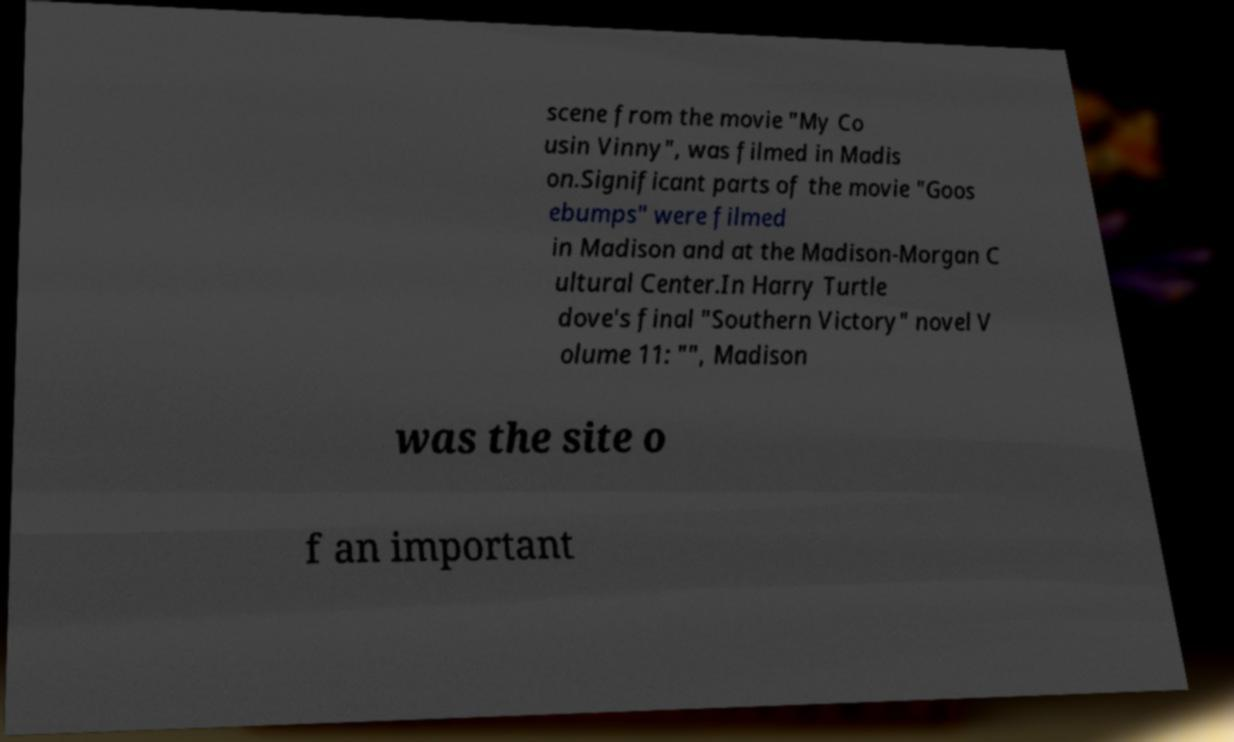Can you read and provide the text displayed in the image?This photo seems to have some interesting text. Can you extract and type it out for me? scene from the movie "My Co usin Vinny", was filmed in Madis on.Significant parts of the movie "Goos ebumps" were filmed in Madison and at the Madison-Morgan C ultural Center.In Harry Turtle dove's final "Southern Victory" novel V olume 11: "", Madison was the site o f an important 